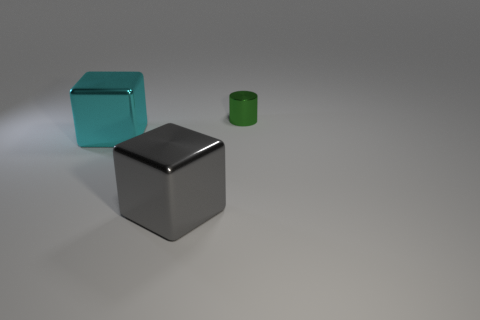Is there any other thing that is the same material as the green cylinder?
Keep it short and to the point. Yes. What number of things are either green matte balls or large things that are to the right of the cyan shiny block?
Your answer should be compact. 1. There is a metallic object that is behind the cyan thing; is it the same size as the cyan thing?
Offer a terse response. No. How many other objects are the same shape as the gray object?
Make the answer very short. 1. How many blue things are small shiny cylinders or big shiny blocks?
Give a very brief answer. 0. There is a large object in front of the large cyan metal thing; does it have the same color as the tiny metallic thing?
Give a very brief answer. No. There is a big thing that is the same material as the large gray cube; what is its shape?
Your response must be concise. Cube. There is a metal object that is both on the right side of the cyan object and left of the cylinder; what color is it?
Provide a short and direct response. Gray. What is the size of the cube that is right of the large object behind the gray cube?
Make the answer very short. Large. Are there any blocks of the same color as the tiny cylinder?
Offer a terse response. No. 